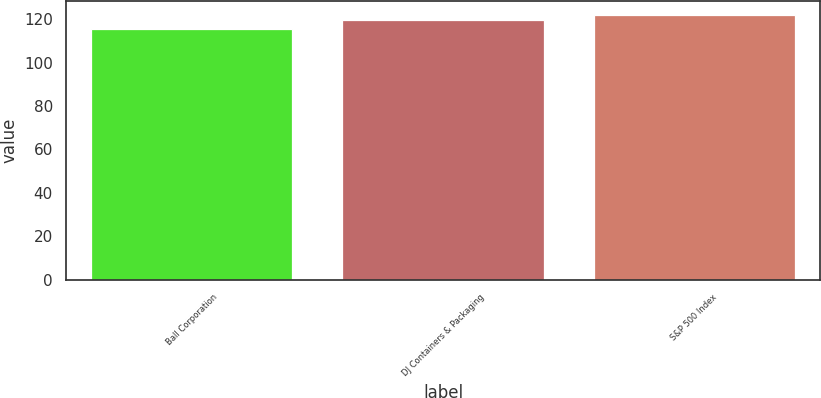Convert chart to OTSL. <chart><loc_0><loc_0><loc_500><loc_500><bar_chart><fcel>Ball Corporation<fcel>DJ Containers & Packaging<fcel>S&P 500 Index<nl><fcel>115.36<fcel>119.63<fcel>122.16<nl></chart> 